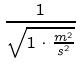<formula> <loc_0><loc_0><loc_500><loc_500>\frac { 1 } { \sqrt { 1 \cdot \frac { m ^ { 2 } } { s ^ { 2 } } } }</formula> 